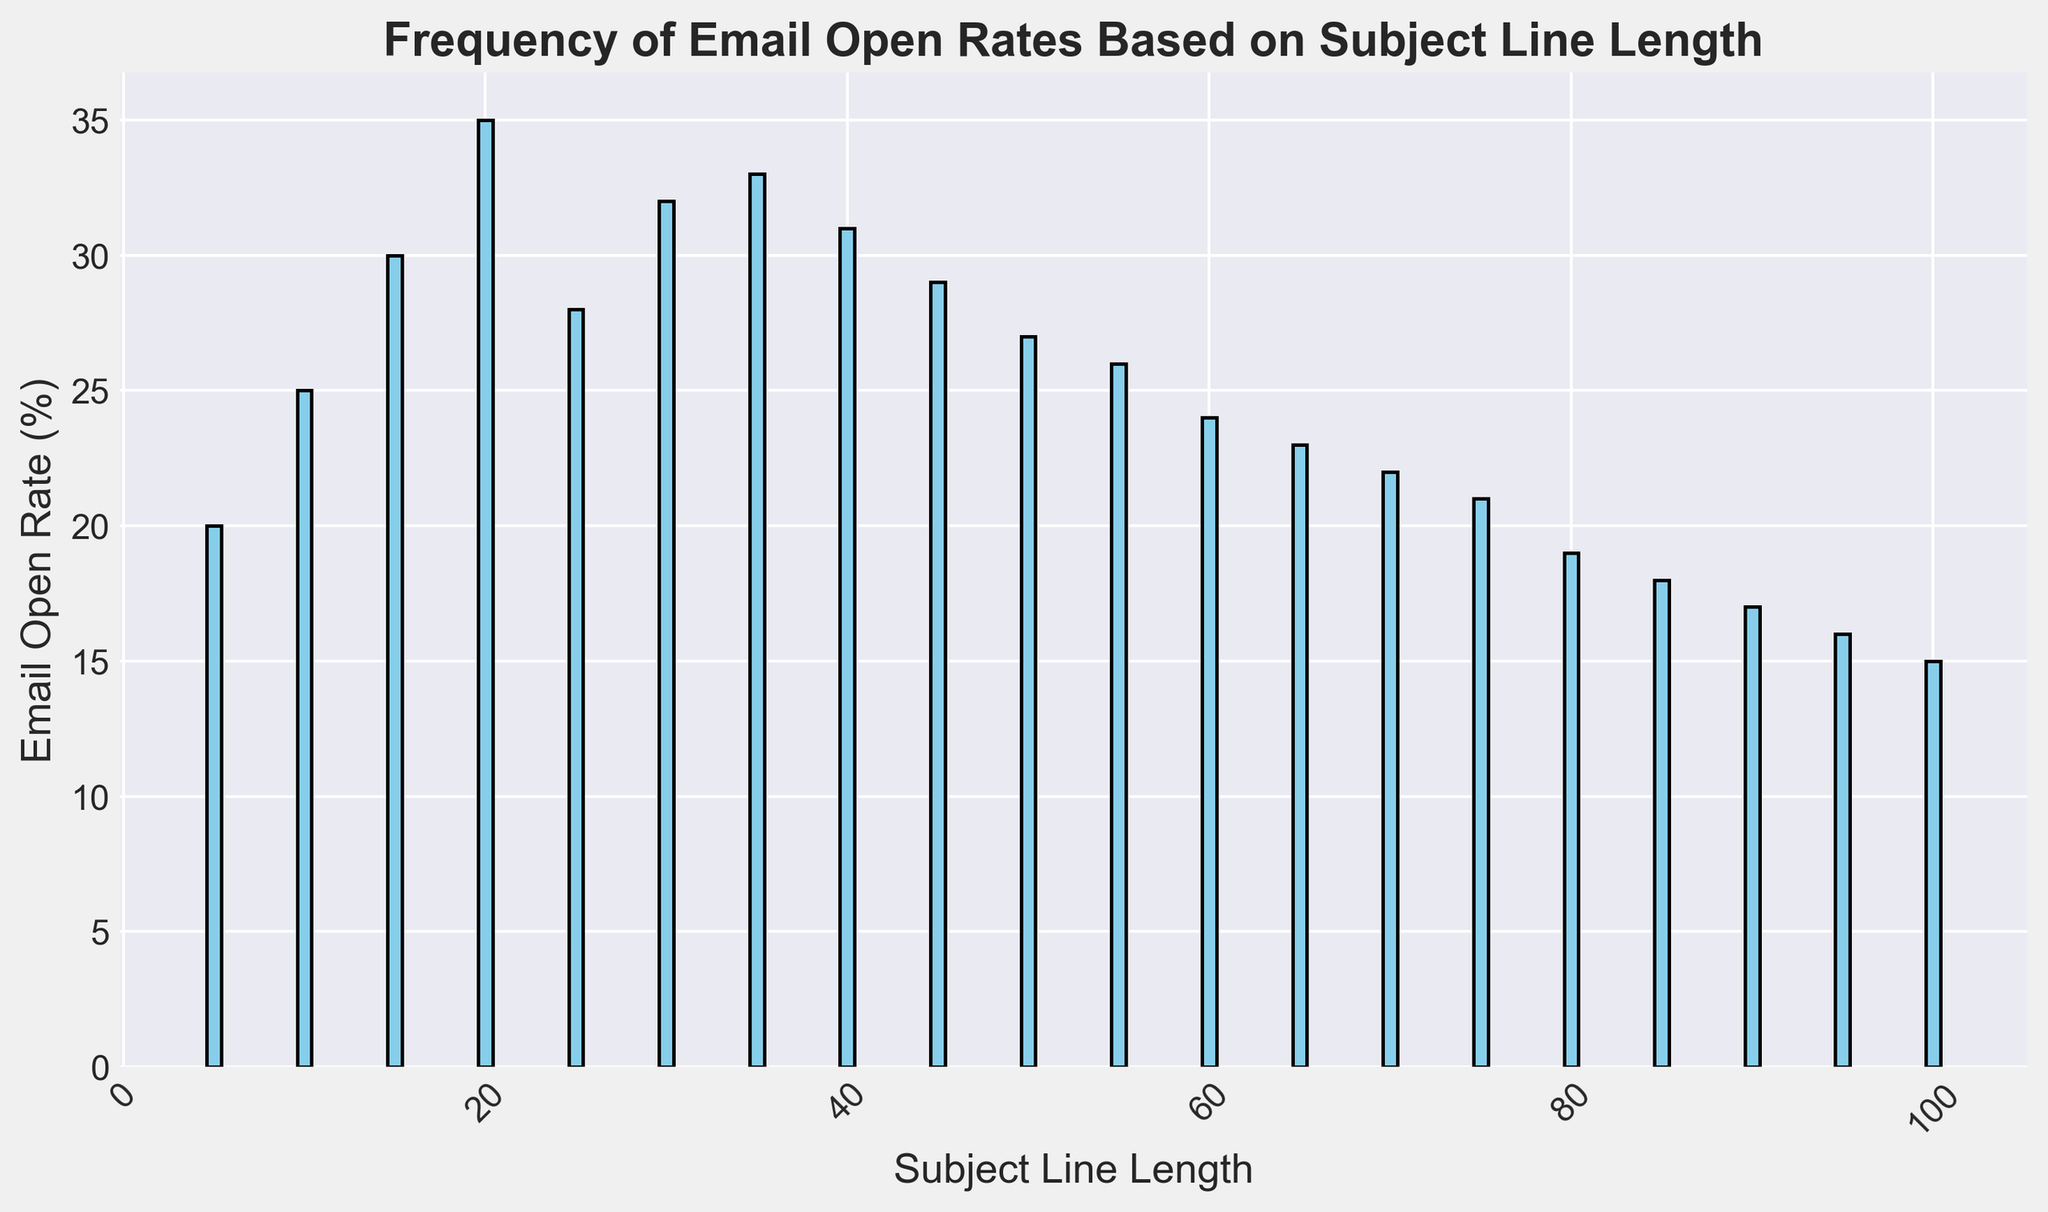What's the subject line length with the highest email open rate? To find the subject line length with the highest email open rate, identify the tallest bar on the histogram. The tallest bar corresponds to a subject line length of 20 with an email open rate of 35%.
Answer: 20 How does the email open rate change as the subject line length increases from 20 to 40? From the figure, observe the email open rates at subject line lengths of 20, 25, 30, 35, and 40. They are 35%, 28%, 32%, 33%, and 31%, respectively. We see an initial drop from 35% to 28% at 25, then a rise to 33% at 35, followed by a slight decrease to 31% at 40.
Answer: Initially decreases, then increases, and decreases again Which subject line length has a lower email open rate: 50 or 70? Locate the bars for subject line lengths of 50 and 70. The heights correspond to email open rates of 27% and 22%, respectively. Since 22% is lower than 27%, the subject line length of 70 has a lower email open rate.
Answer: 70 What is the overall trend of email open rates as subject line length increases from 5 to 100? By observing the heights of the bars from left (5) to right (100), notice that the email open rates generally increase up to a peak at 20, then consistently decrease as the subject line length continues to increase.
Answer: Generally decreasing after a peak at 20 What is the average email open rate for subject line lengths between 20 and 40? Find the email open rates for subject line lengths of 20, 25, 30, 35, and 40, which are 35%, 28%, 32%, 33%, and 31%, respectively. Sum these rates (35 + 28 + 32 + 33 + 31 = 159) and divide by the number of data points (5) to get the average. 159 / 5 = 31.8%.
Answer: 31.8% How many subject line lengths have an email open rate above 30%? Count the bars with email open rates above 30%. These include the subject line lengths of 15, 20, 30, and 35, resulting in four such lengths.
Answer: 4 By how much does the email open rate decrease from the subject line length of 20 to 50? Identify the email open rates for lengths of 20 and 50, which are 35% and 27%, respectively. Find the difference: 35 - 27 = 8%.
Answer: 8% What is the trend in email open rates for subject line lengths longer than 50? Observe the bars for subject line lengths greater than 50. The heights (email open rates) are 26%, 24%, 23%, 22%, 21%, 19%, 18%, 17%, 16%, and 15%, showing a consistent downward trend.
Answer: Decreasing 